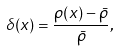<formula> <loc_0><loc_0><loc_500><loc_500>\delta ( x ) = \frac { \rho ( x ) - \bar { \rho } } { \bar { \rho } } ,</formula> 